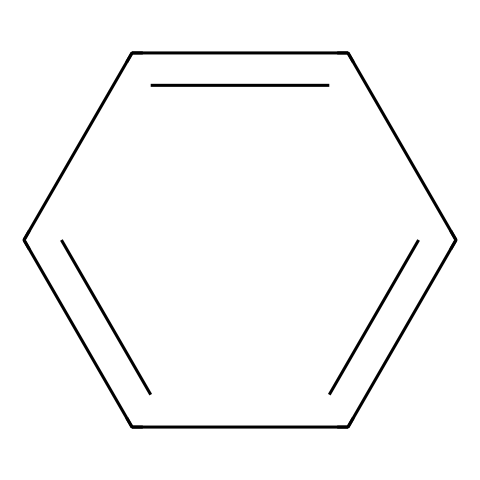What is the chemical name of the compound represented by the SMILES? The SMILES representation corresponds to benzene, which is indicated by its structure of alternating single and double bonds in a six-membered carbon ring.
Answer: benzene How many carbon atoms are present in the structure? The structure shows a six-membered ring with carbon atoms. Each vertex represents a carbon atom, totaling six.
Answer: six How many hydrogen atoms are in the molecule? In benzene, each carbon is bonded to one hydrogen atom, resulting in six hydrogen atoms to maintain tetravalence for the carbon atoms in the aromatic ring.
Answer: six What type of bonding predominates in benzene? The structure indicates alternating double and single bonds in the carbon ring, which is characteristic of aromatic compounds. This demonstrates resonance and provides benzene its stability.
Answer: resonance Is benzene an aromatic compound? The cyclic structure with alternating double bonds fulfills Huckel's rule (4n+2 π electrons), confirming that benzene is aromatic due to its unique electronic configuration.
Answer: yes What is the molecular formula of benzene? The combination of six carbon atoms and six hydrogen atoms leads to the molecular formula C6H6, which is characteristic for benzene.
Answer: C6H6 How does the structure of benzene contribute to its use as a solvent? The stability provided by resonance and non-polar character allows benzene to effectively dissolve a wide range of organic compounds, making it a preferred solvent in various applications, including film production.
Answer: stability and non-polarity 